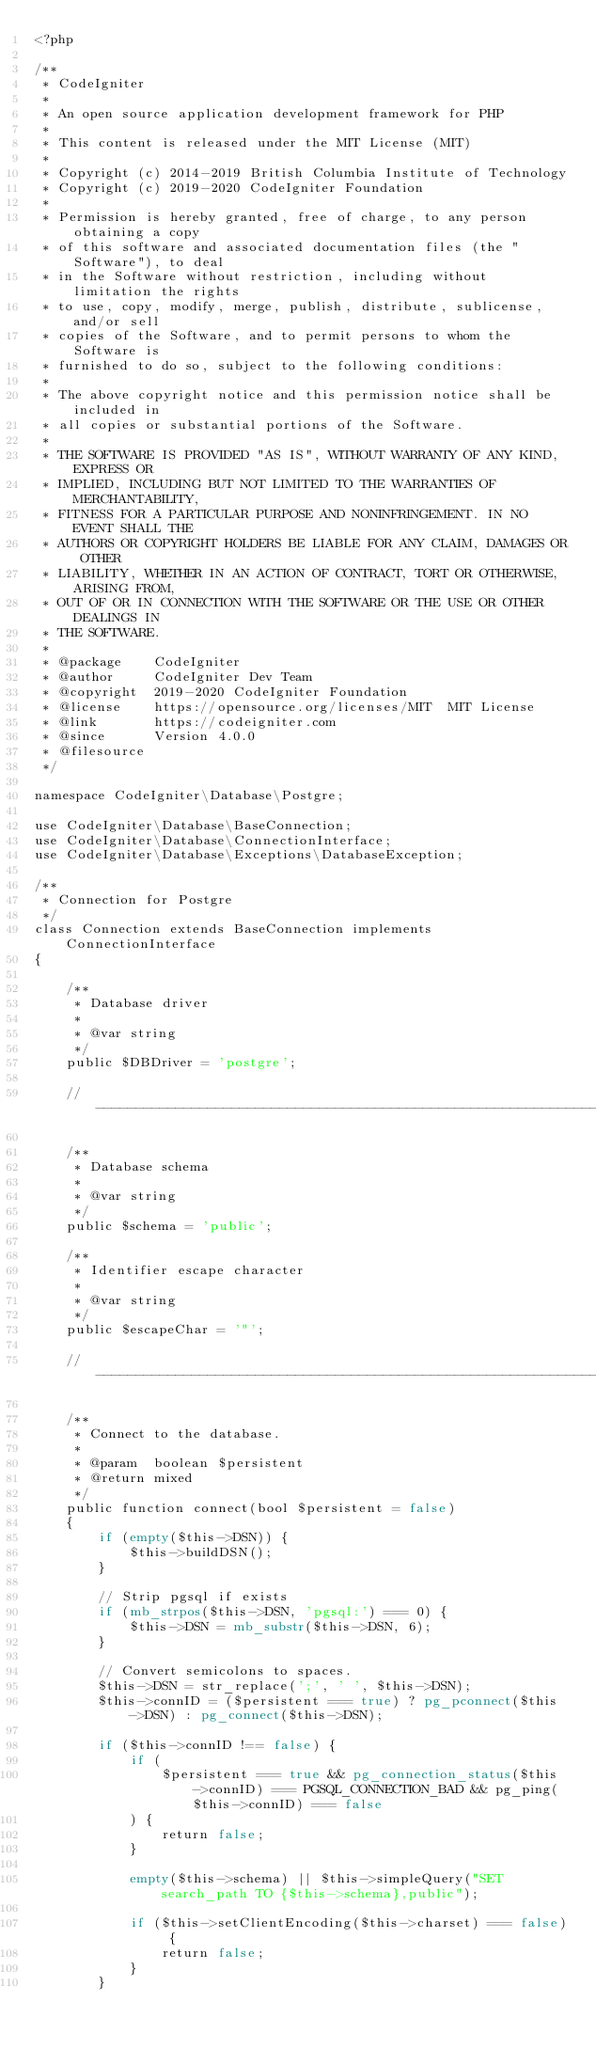<code> <loc_0><loc_0><loc_500><loc_500><_PHP_><?php

/**
 * CodeIgniter
 *
 * An open source application development framework for PHP
 *
 * This content is released under the MIT License (MIT)
 *
 * Copyright (c) 2014-2019 British Columbia Institute of Technology
 * Copyright (c) 2019-2020 CodeIgniter Foundation
 *
 * Permission is hereby granted, free of charge, to any person obtaining a copy
 * of this software and associated documentation files (the "Software"), to deal
 * in the Software without restriction, including without limitation the rights
 * to use, copy, modify, merge, publish, distribute, sublicense, and/or sell
 * copies of the Software, and to permit persons to whom the Software is
 * furnished to do so, subject to the following conditions:
 *
 * The above copyright notice and this permission notice shall be included in
 * all copies or substantial portions of the Software.
 *
 * THE SOFTWARE IS PROVIDED "AS IS", WITHOUT WARRANTY OF ANY KIND, EXPRESS OR
 * IMPLIED, INCLUDING BUT NOT LIMITED TO THE WARRANTIES OF MERCHANTABILITY,
 * FITNESS FOR A PARTICULAR PURPOSE AND NONINFRINGEMENT. IN NO EVENT SHALL THE
 * AUTHORS OR COPYRIGHT HOLDERS BE LIABLE FOR ANY CLAIM, DAMAGES OR OTHER
 * LIABILITY, WHETHER IN AN ACTION OF CONTRACT, TORT OR OTHERWISE, ARISING FROM,
 * OUT OF OR IN CONNECTION WITH THE SOFTWARE OR THE USE OR OTHER DEALINGS IN
 * THE SOFTWARE.
 *
 * @package    CodeIgniter
 * @author     CodeIgniter Dev Team
 * @copyright  2019-2020 CodeIgniter Foundation
 * @license    https://opensource.org/licenses/MIT	MIT License
 * @link       https://codeigniter.com
 * @since      Version 4.0.0
 * @filesource
 */

namespace CodeIgniter\Database\Postgre;

use CodeIgniter\Database\BaseConnection;
use CodeIgniter\Database\ConnectionInterface;
use CodeIgniter\Database\Exceptions\DatabaseException;

/**
 * Connection for Postgre
 */
class Connection extends BaseConnection implements ConnectionInterface
{

	/**
	 * Database driver
	 *
	 * @var string
	 */
	public $DBDriver = 'postgre';

	//--------------------------------------------------------------------

	/**
	 * Database schema
	 *
	 * @var string
	 */
	public $schema = 'public';

	/**
	 * Identifier escape character
	 *
	 * @var string
	 */
	public $escapeChar = '"';

	//--------------------------------------------------------------------

	/**
	 * Connect to the database.
	 *
	 * @param  boolean $persistent
	 * @return mixed
	 */
	public function connect(bool $persistent = false)
	{
		if (empty($this->DSN)) {
			$this->buildDSN();
		}

		// Strip pgsql if exists
		if (mb_strpos($this->DSN, 'pgsql:') === 0) {
			$this->DSN = mb_substr($this->DSN, 6);
		}

		// Convert semicolons to spaces.
		$this->DSN = str_replace(';', ' ', $this->DSN);
		$this->connID = ($persistent === true) ? pg_pconnect($this->DSN) : pg_connect($this->DSN);

		if ($this->connID !== false) {
			if (
				$persistent === true && pg_connection_status($this->connID) === PGSQL_CONNECTION_BAD && pg_ping($this->connID) === false
			) {
				return false;
			}

			empty($this->schema) || $this->simpleQuery("SET search_path TO {$this->schema},public");

			if ($this->setClientEncoding($this->charset) === false) {
				return false;
			}
		}
</code> 